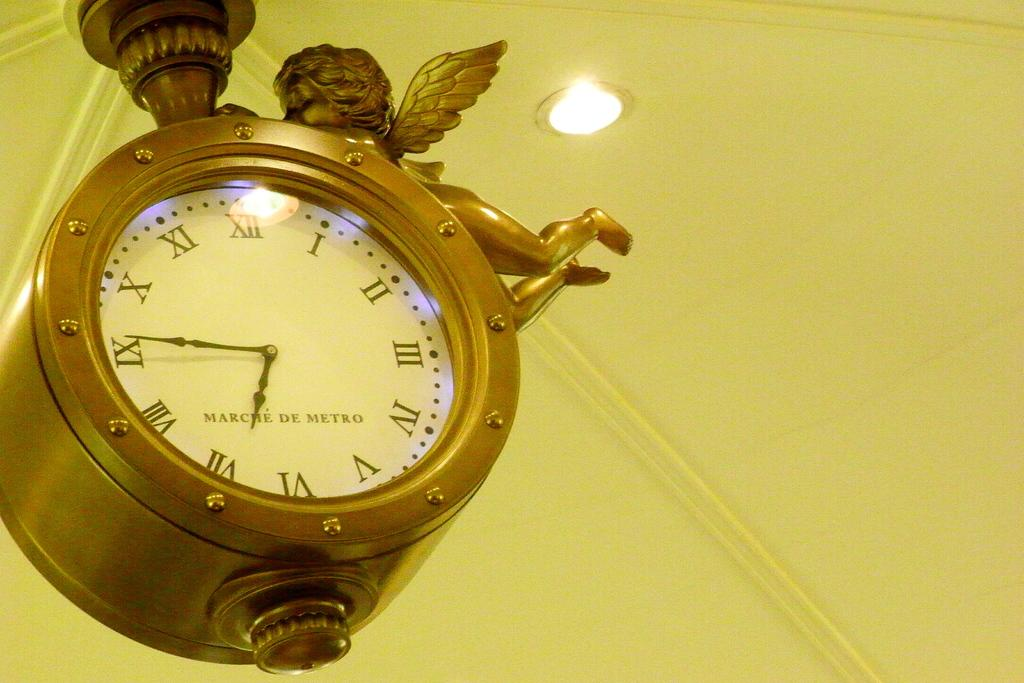<image>
Give a short and clear explanation of the subsequent image. The gold clock hanging on the ceiling reads 6:45. 